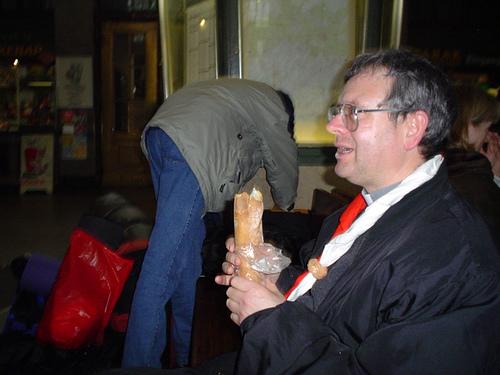What is the man holding?
Keep it brief. Sandwich. Is this man eating?
Be succinct. Yes. Where is the man staring?
Concise answer only. Distance. Is he wearing glasses?
Give a very brief answer. Yes. 